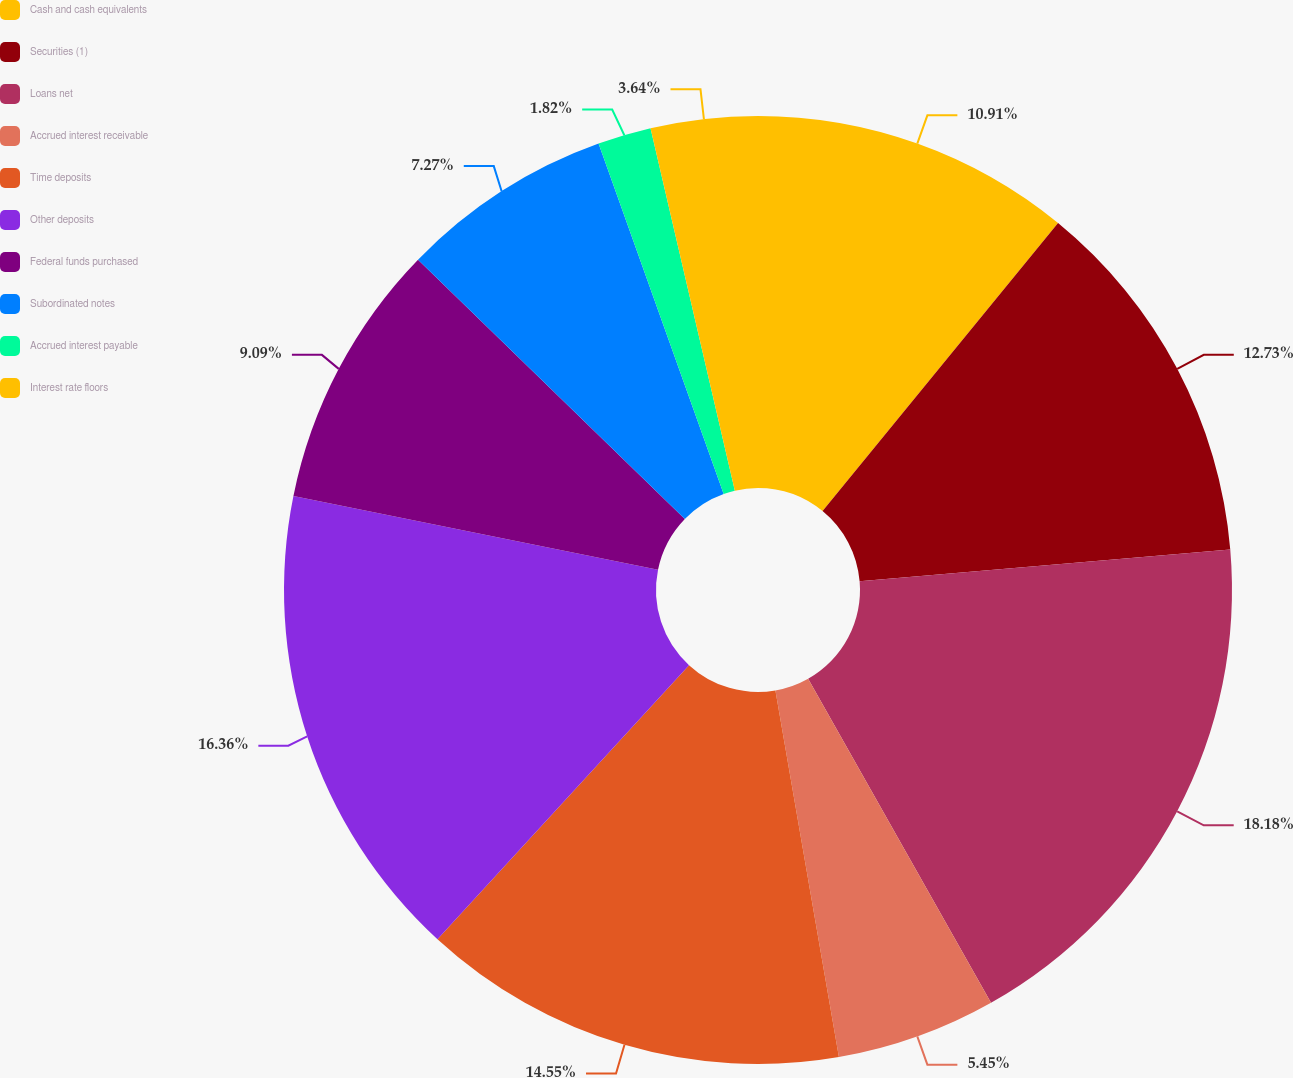<chart> <loc_0><loc_0><loc_500><loc_500><pie_chart><fcel>Cash and cash equivalents<fcel>Securities (1)<fcel>Loans net<fcel>Accrued interest receivable<fcel>Time deposits<fcel>Other deposits<fcel>Federal funds purchased<fcel>Subordinated notes<fcel>Accrued interest payable<fcel>Interest rate floors<nl><fcel>10.91%<fcel>12.73%<fcel>18.18%<fcel>5.45%<fcel>14.55%<fcel>16.36%<fcel>9.09%<fcel>7.27%<fcel>1.82%<fcel>3.64%<nl></chart> 